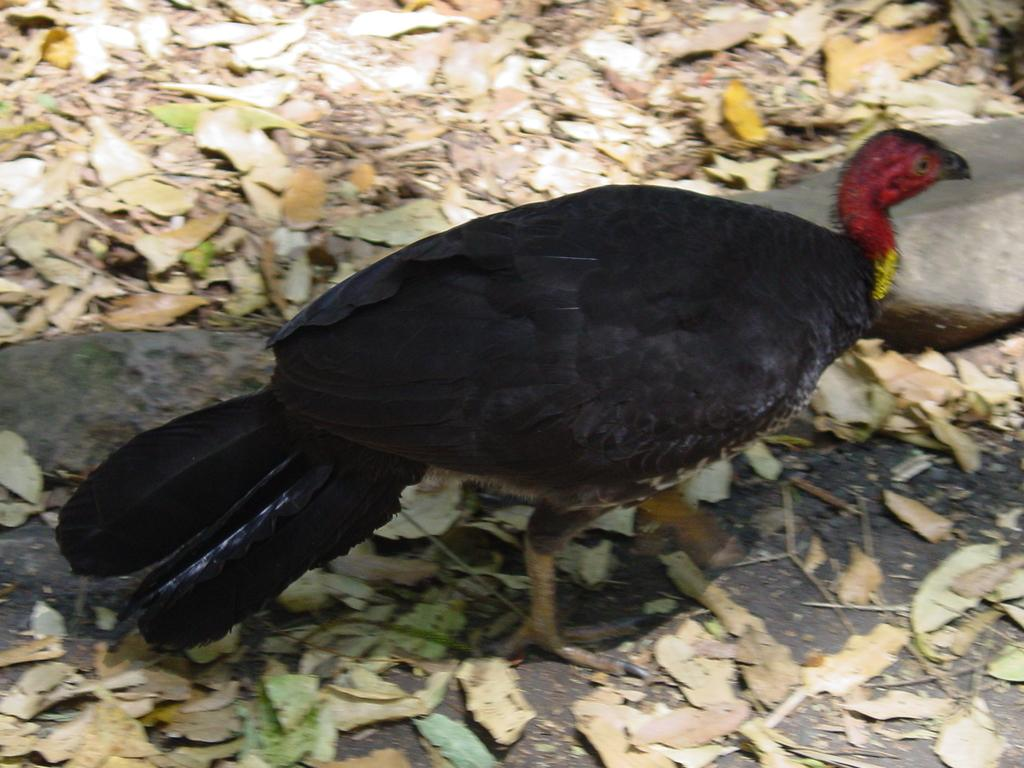What animal is in the front of the image? There is a bird in the front of the image. What type of vegetation is at the bottom of the image? There are leaves at the bottom of the image. What object is on the right side of the image? There is a stone on the right side of the image. How many ladybugs are crawling on the stone in the image? There are no ladybugs present in the image. What type of liquid is being dropped from the bird in the image? The bird in the image is not depicted as dropping any liquid. 